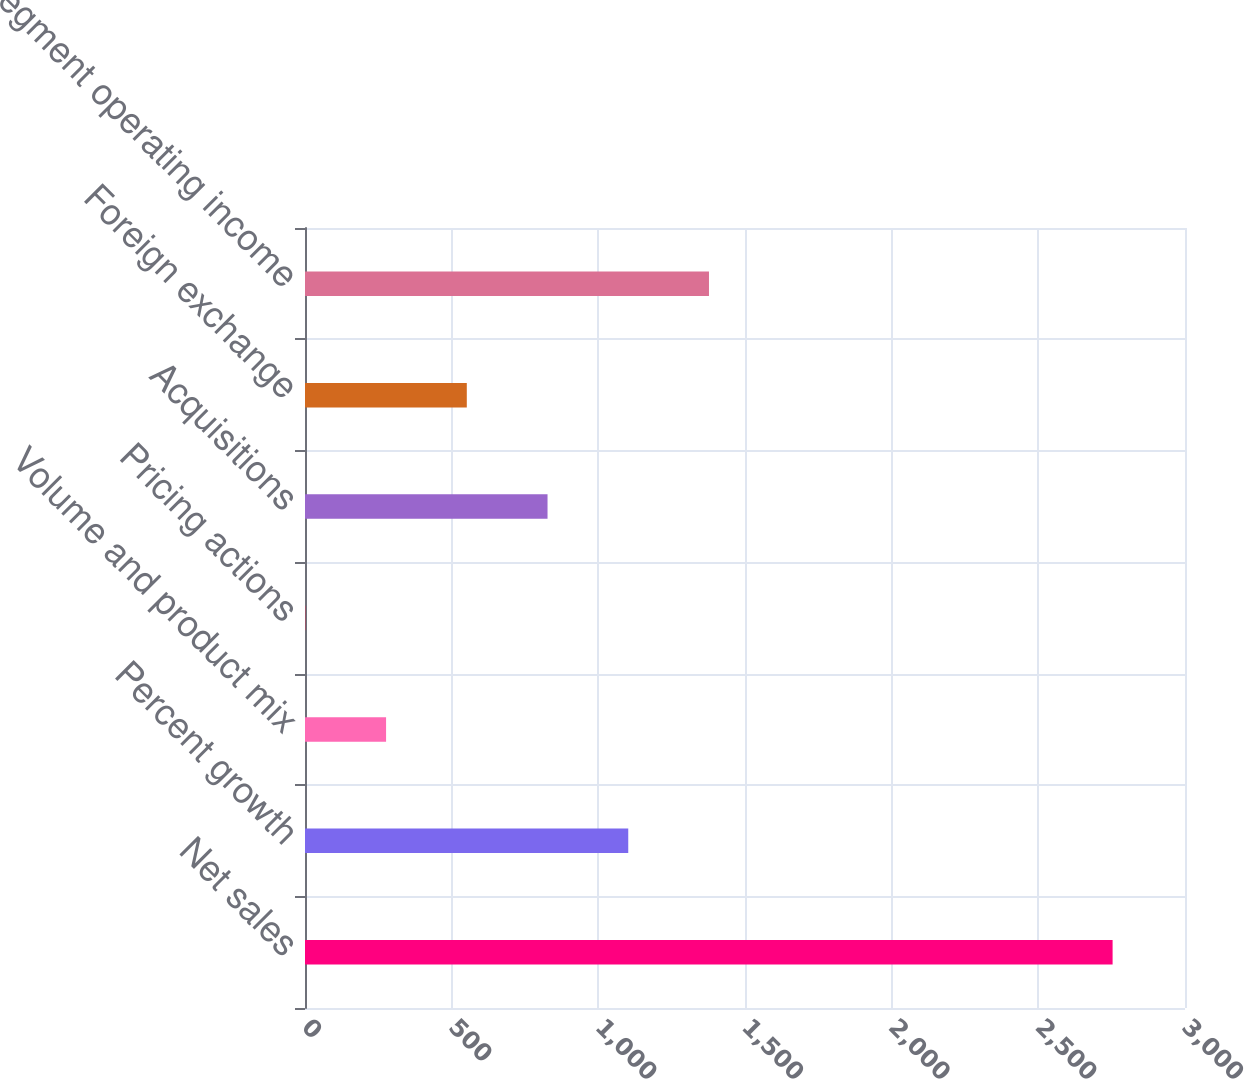<chart> <loc_0><loc_0><loc_500><loc_500><bar_chart><fcel>Net sales<fcel>Percent growth<fcel>Volume and product mix<fcel>Pricing actions<fcel>Acquisitions<fcel>Foreign exchange<fcel>Segment operating income<nl><fcel>2753.2<fcel>1102<fcel>276.4<fcel>1.2<fcel>826.8<fcel>551.6<fcel>1377.2<nl></chart> 